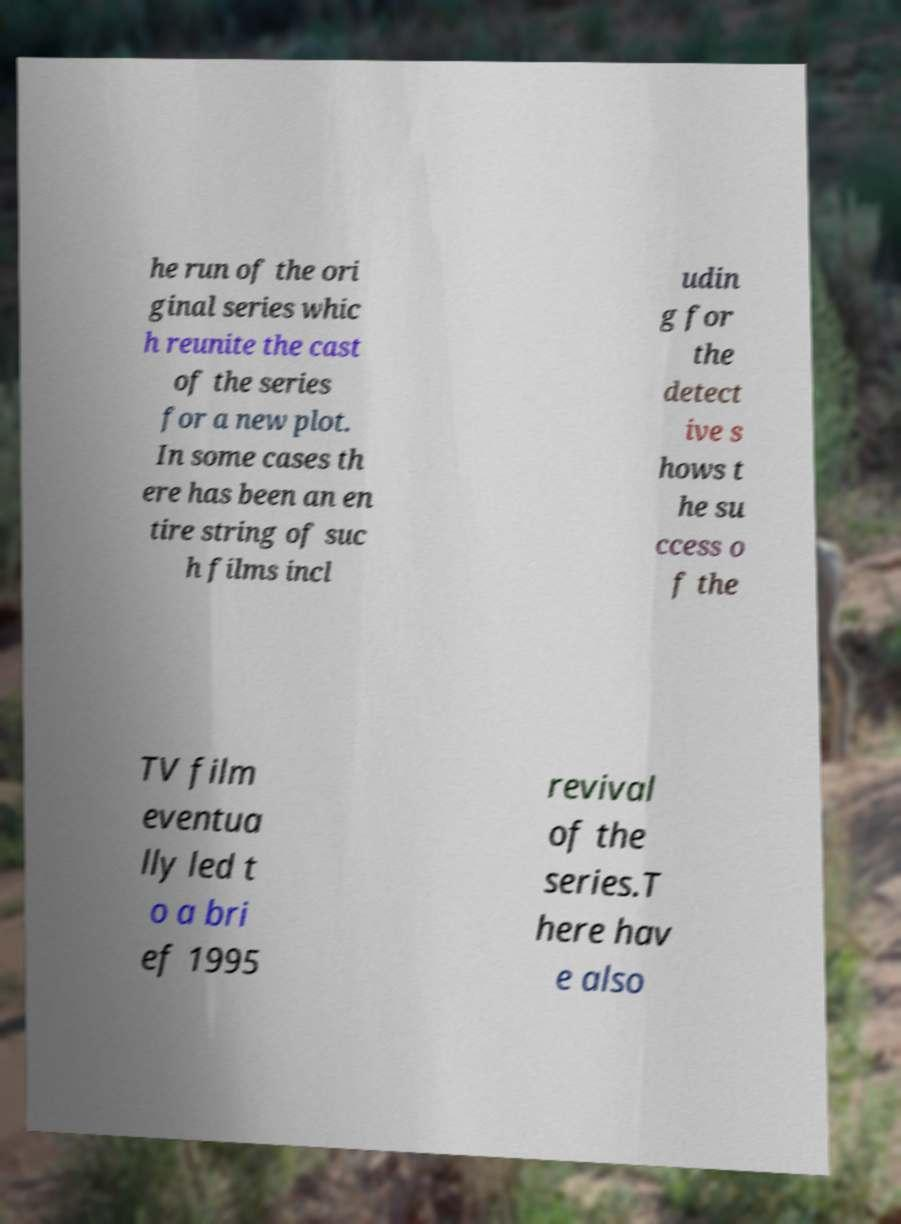I need the written content from this picture converted into text. Can you do that? he run of the ori ginal series whic h reunite the cast of the series for a new plot. In some cases th ere has been an en tire string of suc h films incl udin g for the detect ive s hows t he su ccess o f the TV film eventua lly led t o a bri ef 1995 revival of the series.T here hav e also 